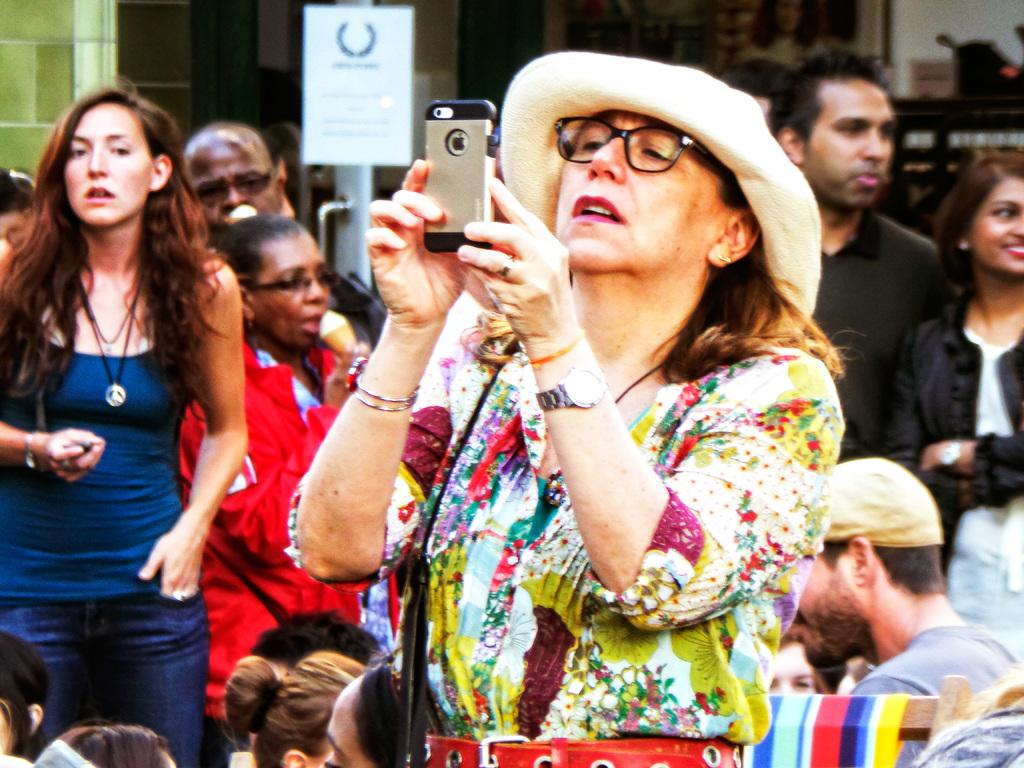Who is the main subject in the image? There is a woman in the image. What is the woman wearing? The woman is wearing a floral dress and a hat. What object is the woman holding? The woman is holding a cellphone. Can you describe the background of the image? There are many people standing behind the woman. What type of vase can be seen on the woman's head in the image? There is no vase present on the woman's head in the image. How does the ray of sunlight affect the woman's appearance in the image? There is no mention of sunlight or any other light source in the image, so it is not possible to determine its effect on the woman's appearance. 